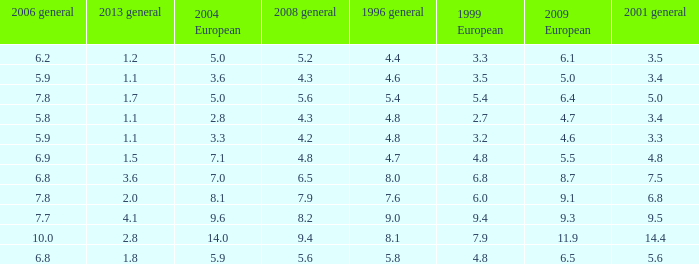What is the average value for general 2001 with more than 4.8 in 1999 European, 7.7 in 2006 general, and more than 9 in 1996 general? None. 